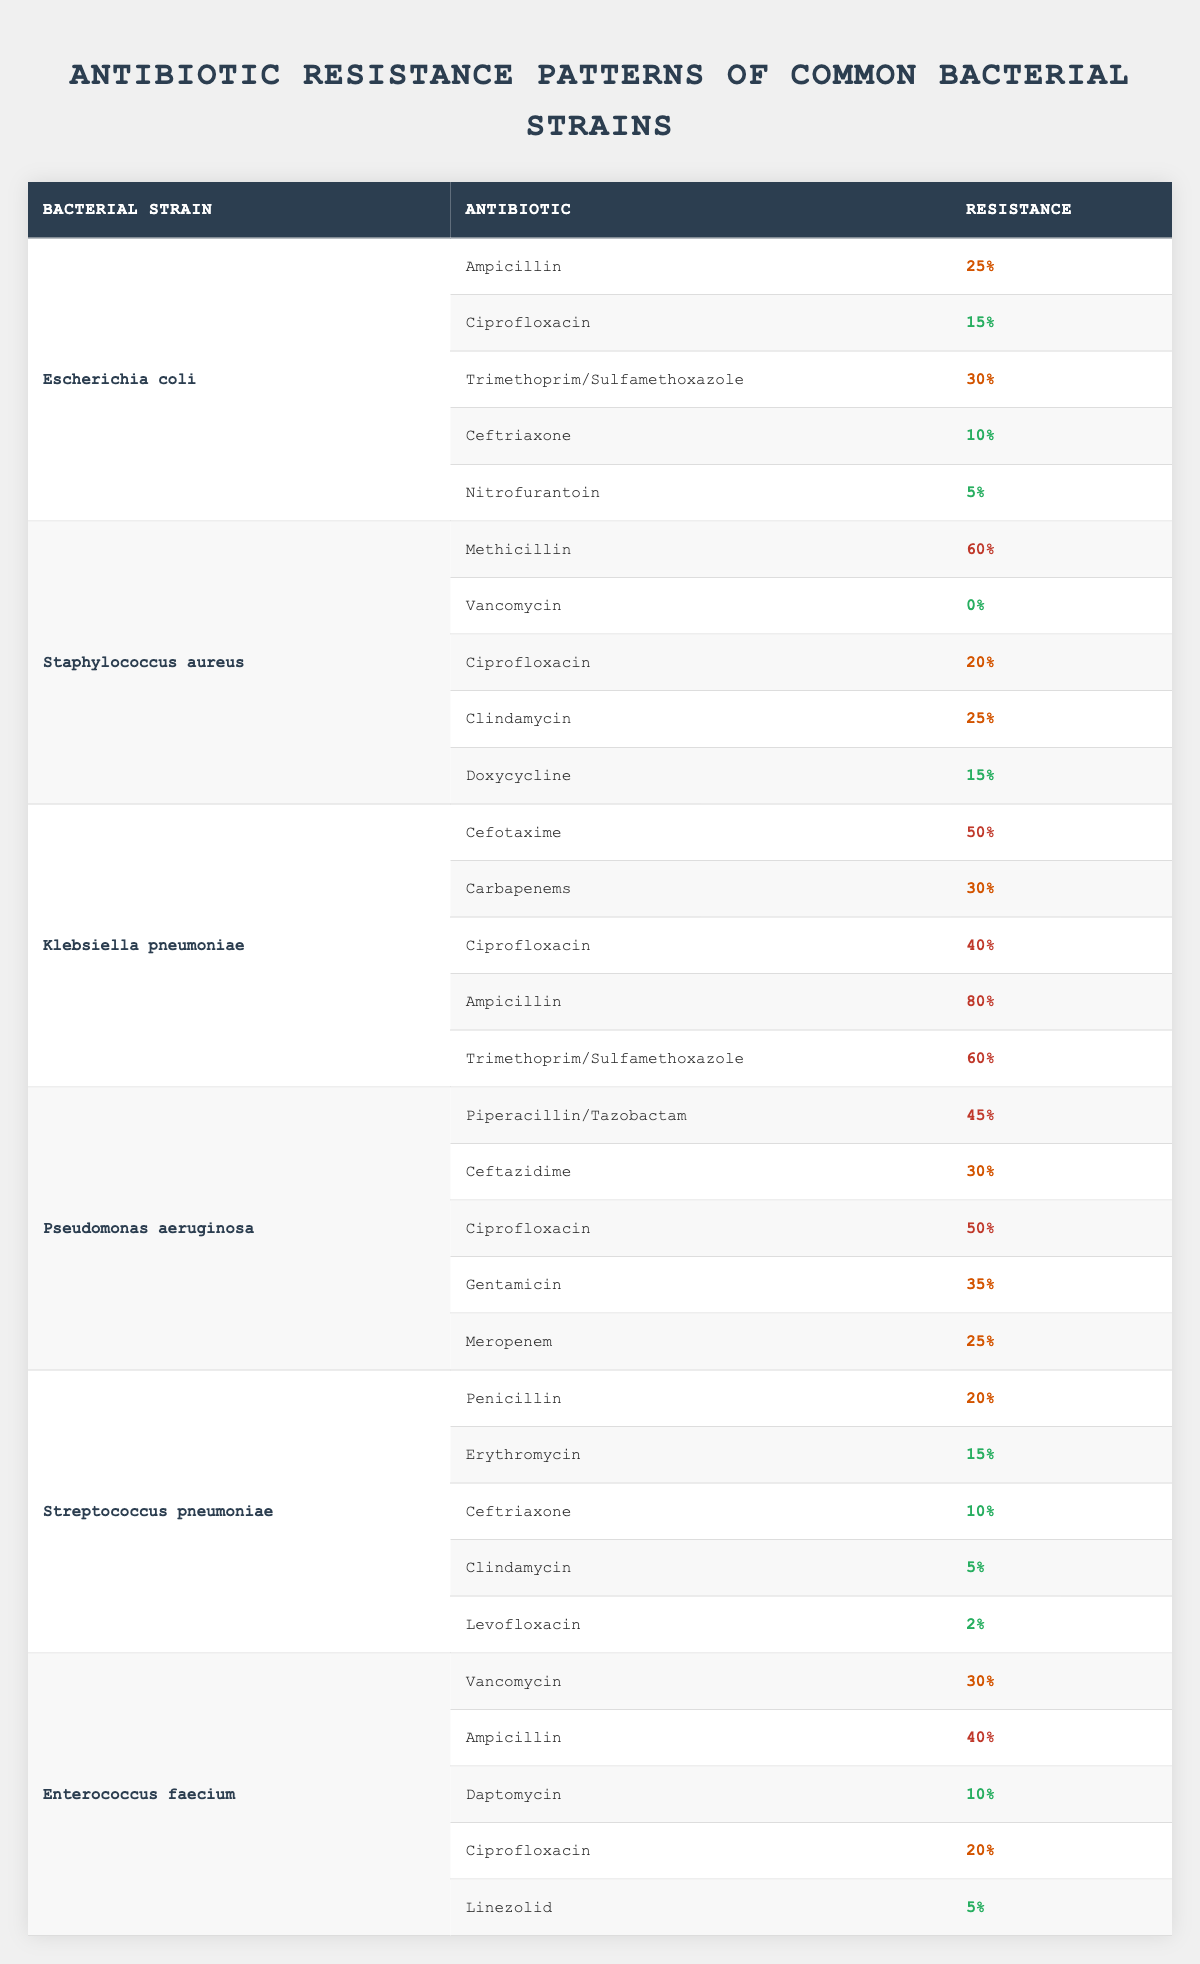What is the resistance percentage of Escherichia coli to Nitrofurantoin? From the table, under the row for Escherichia coli, the resistance percentage for Nitrofurantoin is listed as 5%.
Answer: 5% Which bacterial strain shows the highest resistance to Ampicillin? Looking at the resistance patterns, Klebsiella pneumoniae has the highest resistance percentage to Ampicillin, at 80%.
Answer: Klebsiella pneumoniae What is the average resistance percentage of Staphylococcus aureus to the antibiotics listed? The resistance percentages for Staphylococcus aureus are 60%, 0%, 20%, 25%, and 15%. Adding these gives 120%, and dividing by 5 (the number of antibiotics) results in an average of 24%.
Answer: 24% Is the resistance of Streptococcus pneumoniae to Erythromycin higher than to Levofloxacin? The resistance percentage for Erythromycin is 15% and for Levofloxacin is 2%. Since 15% is greater than 2%, the statement is true.
Answer: Yes How many bacterial strains have a resistance percentage of over 50% to any antibiotic listed? Examining the data, Klebsiella pneumoniae has Ampicillin (80%) and Trimethoprim/Sulfamethoxazole (60%); Staphylococcus aureus has Methicillin (60%); Pseudomonas aeruginosa has Ciprofloxacin (50%). Thus, there are 3 strains with resistance over 50%.
Answer: 3 What is the total resistance percentage for Klebsiella pneumoniae across all antibiotics? The resistance percentages are 50%, 30%, 40%, 80%, and 60%. The total is 50 + 30 + 40 + 80 + 60 = 260%.
Answer: 260% Which antibiotic has the lowest resistance percentage for Enterococcus faecium? The resistance percentages for Enterococcus faecium are 30%, 40%, 10%, 20%, and 5%. The lowest percentage is for Linezolid at 5%.
Answer: Linezolid Is there an antibiotic that has a 0% resistance percentage across all strains listed? Observing the table, Vancomycin shows a resistance percentage of 0% for Staphylococcus aureus, but it is not present for all strains, so the answer is no.
Answer: No What is the combined resistance percentage of Pseudomonas aeruginosa to Ciprofloxacin and Meropenem? For Pseudomonas aeruginosa, the resistance to Ciprofloxacin is 50% and to Meropenem is 25%. Adding these gives 50 + 25 = 75%.
Answer: 75% How does the resistance of Klebsiella pneumoniae to Ciprofloxacin compare to that of Pseudomonas aeruginosa? The resistance percentage for Klebsiella pneumoniae to Ciprofloxacin is 40%, while for Pseudomonas aeruginosa it is 50%. Therefore, Pseudomonas aeruginosa has a higher resistance.
Answer: Pseudomonas aeruginosa Which strain has no resistance to Vancomycin? The table shows that Staphylococcus aureus has a resistance of 0% to Vancomycin, confirming that it has no resistance.
Answer: Staphylococcus aureus 